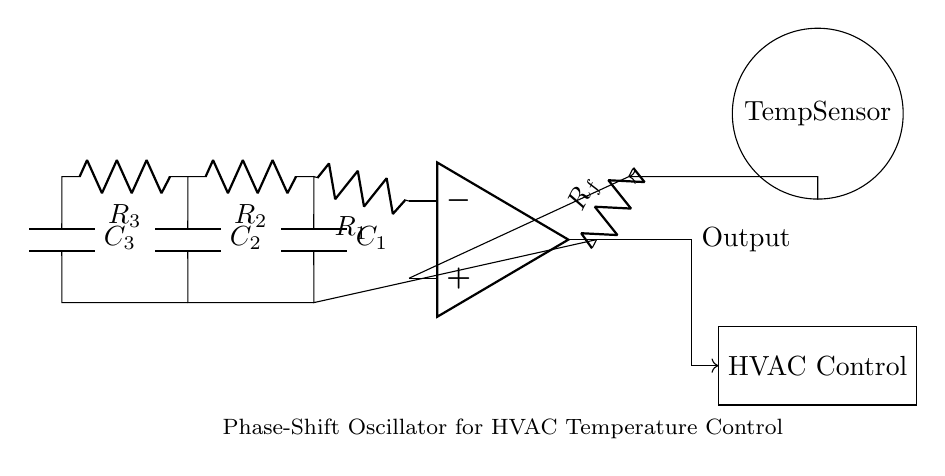What type of components are primarily used in this circuit? The circuit primarily uses resistors, capacitors, and an operational amplifier. These components are integral for creating the oscillation function of the circuit.
Answer: resistors, capacitors, operational amplifier What is the function of the temperature sensor in this circuit? The temperature sensor provides feedback to the circuit based on the current temperature, playing a crucial role in the temperature control of the HVAC system.
Answer: feedback for temperature control How many resistors are present in the circuit diagram? There are four resistors shown in the circuit: R1, R2, R3, and Rf. The count of the resistors can be obtained by visually counting them in the diagram.
Answer: four Which component provides the output signal for the HVAC control? The output signal is provided by the operational amplifier, which processes the input signals and generates the output based on the feedback received.
Answer: operational amplifier What is the purpose of the feedback resistor in the circuit? The feedback resistor Rf allows part of the output signal to return to the input side of the operational amplifier, which stabilizes and regulates the oscillation produced by the circuit.
Answer: stabilize oscillation How does the arrangement of capacitors affect the phase shift? The arrangement of capacitors in conjunction with resistors creates the required phase shift necessary for oscillation; three capacitors result in a total phase shift of 180 degrees, which is essential for the oscillator's feedback mechanism.
Answer: creates phase shift What role does the operational amplifier play in the oscillator circuit? The operational amplifier amplifies the voltage differences and contributes to the overall gain needed for the oscillation process, functioning as a pivotal component for generating oscillations.
Answer: amplifies voltage differences 